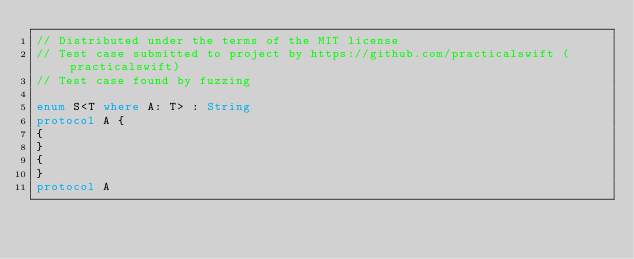Convert code to text. <code><loc_0><loc_0><loc_500><loc_500><_Swift_>// Distributed under the terms of the MIT license
// Test case submitted to project by https://github.com/practicalswift (practicalswift)
// Test case found by fuzzing

enum S<T where A: T> : String
protocol A {
{
}
{
}
protocol A
</code> 